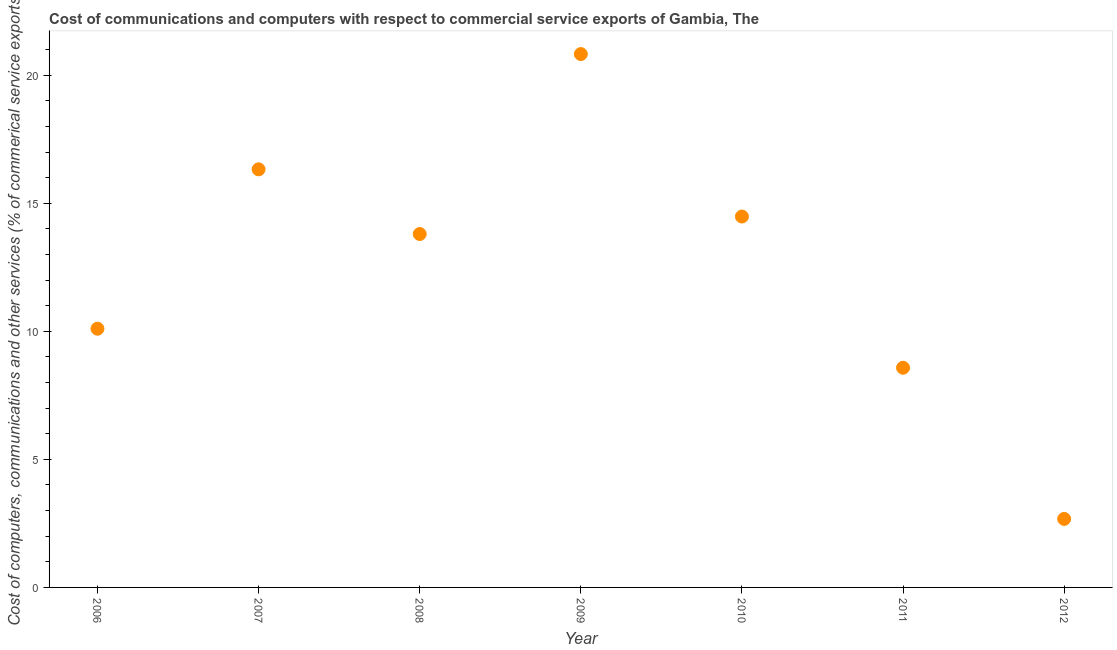What is the cost of communications in 2006?
Your answer should be compact. 10.1. Across all years, what is the maximum  computer and other services?
Ensure brevity in your answer.  20.83. Across all years, what is the minimum cost of communications?
Provide a short and direct response. 2.68. In which year was the cost of communications minimum?
Offer a very short reply. 2012. What is the sum of the cost of communications?
Provide a short and direct response. 86.79. What is the difference between the cost of communications in 2007 and 2012?
Your answer should be compact. 13.65. What is the average cost of communications per year?
Your response must be concise. 12.4. What is the median cost of communications?
Provide a succinct answer. 13.8. In how many years, is the cost of communications greater than 6 %?
Keep it short and to the point. 6. What is the ratio of the  computer and other services in 2008 to that in 2012?
Ensure brevity in your answer.  5.16. Is the  computer and other services in 2007 less than that in 2009?
Give a very brief answer. Yes. What is the difference between the highest and the second highest  computer and other services?
Provide a succinct answer. 4.5. What is the difference between the highest and the lowest  computer and other services?
Provide a succinct answer. 18.15. In how many years, is the  computer and other services greater than the average  computer and other services taken over all years?
Provide a succinct answer. 4. Does the cost of communications monotonically increase over the years?
Make the answer very short. No. What is the difference between two consecutive major ticks on the Y-axis?
Ensure brevity in your answer.  5. Does the graph contain any zero values?
Your answer should be very brief. No. What is the title of the graph?
Provide a succinct answer. Cost of communications and computers with respect to commercial service exports of Gambia, The. What is the label or title of the X-axis?
Your answer should be compact. Year. What is the label or title of the Y-axis?
Make the answer very short. Cost of computers, communications and other services (% of commerical service exports). What is the Cost of computers, communications and other services (% of commerical service exports) in 2006?
Give a very brief answer. 10.1. What is the Cost of computers, communications and other services (% of commerical service exports) in 2007?
Your answer should be compact. 16.33. What is the Cost of computers, communications and other services (% of commerical service exports) in 2008?
Give a very brief answer. 13.8. What is the Cost of computers, communications and other services (% of commerical service exports) in 2009?
Keep it short and to the point. 20.83. What is the Cost of computers, communications and other services (% of commerical service exports) in 2010?
Offer a terse response. 14.48. What is the Cost of computers, communications and other services (% of commerical service exports) in 2011?
Provide a succinct answer. 8.58. What is the Cost of computers, communications and other services (% of commerical service exports) in 2012?
Your answer should be compact. 2.68. What is the difference between the Cost of computers, communications and other services (% of commerical service exports) in 2006 and 2007?
Your answer should be compact. -6.22. What is the difference between the Cost of computers, communications and other services (% of commerical service exports) in 2006 and 2008?
Offer a very short reply. -3.7. What is the difference between the Cost of computers, communications and other services (% of commerical service exports) in 2006 and 2009?
Offer a terse response. -10.72. What is the difference between the Cost of computers, communications and other services (% of commerical service exports) in 2006 and 2010?
Offer a terse response. -4.38. What is the difference between the Cost of computers, communications and other services (% of commerical service exports) in 2006 and 2011?
Offer a very short reply. 1.52. What is the difference between the Cost of computers, communications and other services (% of commerical service exports) in 2006 and 2012?
Provide a succinct answer. 7.43. What is the difference between the Cost of computers, communications and other services (% of commerical service exports) in 2007 and 2008?
Your answer should be very brief. 2.53. What is the difference between the Cost of computers, communications and other services (% of commerical service exports) in 2007 and 2009?
Make the answer very short. -4.5. What is the difference between the Cost of computers, communications and other services (% of commerical service exports) in 2007 and 2010?
Offer a terse response. 1.84. What is the difference between the Cost of computers, communications and other services (% of commerical service exports) in 2007 and 2011?
Provide a short and direct response. 7.75. What is the difference between the Cost of computers, communications and other services (% of commerical service exports) in 2007 and 2012?
Your answer should be compact. 13.65. What is the difference between the Cost of computers, communications and other services (% of commerical service exports) in 2008 and 2009?
Provide a succinct answer. -7.03. What is the difference between the Cost of computers, communications and other services (% of commerical service exports) in 2008 and 2010?
Make the answer very short. -0.68. What is the difference between the Cost of computers, communications and other services (% of commerical service exports) in 2008 and 2011?
Ensure brevity in your answer.  5.22. What is the difference between the Cost of computers, communications and other services (% of commerical service exports) in 2008 and 2012?
Your answer should be compact. 11.12. What is the difference between the Cost of computers, communications and other services (% of commerical service exports) in 2009 and 2010?
Provide a succinct answer. 6.34. What is the difference between the Cost of computers, communications and other services (% of commerical service exports) in 2009 and 2011?
Keep it short and to the point. 12.25. What is the difference between the Cost of computers, communications and other services (% of commerical service exports) in 2009 and 2012?
Your response must be concise. 18.15. What is the difference between the Cost of computers, communications and other services (% of commerical service exports) in 2010 and 2011?
Offer a very short reply. 5.9. What is the difference between the Cost of computers, communications and other services (% of commerical service exports) in 2010 and 2012?
Offer a terse response. 11.81. What is the difference between the Cost of computers, communications and other services (% of commerical service exports) in 2011 and 2012?
Your answer should be very brief. 5.9. What is the ratio of the Cost of computers, communications and other services (% of commerical service exports) in 2006 to that in 2007?
Make the answer very short. 0.62. What is the ratio of the Cost of computers, communications and other services (% of commerical service exports) in 2006 to that in 2008?
Your answer should be compact. 0.73. What is the ratio of the Cost of computers, communications and other services (% of commerical service exports) in 2006 to that in 2009?
Ensure brevity in your answer.  0.48. What is the ratio of the Cost of computers, communications and other services (% of commerical service exports) in 2006 to that in 2010?
Offer a terse response. 0.7. What is the ratio of the Cost of computers, communications and other services (% of commerical service exports) in 2006 to that in 2011?
Provide a succinct answer. 1.18. What is the ratio of the Cost of computers, communications and other services (% of commerical service exports) in 2006 to that in 2012?
Offer a very short reply. 3.78. What is the ratio of the Cost of computers, communications and other services (% of commerical service exports) in 2007 to that in 2008?
Your answer should be compact. 1.18. What is the ratio of the Cost of computers, communications and other services (% of commerical service exports) in 2007 to that in 2009?
Provide a short and direct response. 0.78. What is the ratio of the Cost of computers, communications and other services (% of commerical service exports) in 2007 to that in 2010?
Your response must be concise. 1.13. What is the ratio of the Cost of computers, communications and other services (% of commerical service exports) in 2007 to that in 2011?
Give a very brief answer. 1.9. What is the ratio of the Cost of computers, communications and other services (% of commerical service exports) in 2007 to that in 2012?
Make the answer very short. 6.1. What is the ratio of the Cost of computers, communications and other services (% of commerical service exports) in 2008 to that in 2009?
Provide a succinct answer. 0.66. What is the ratio of the Cost of computers, communications and other services (% of commerical service exports) in 2008 to that in 2010?
Make the answer very short. 0.95. What is the ratio of the Cost of computers, communications and other services (% of commerical service exports) in 2008 to that in 2011?
Ensure brevity in your answer.  1.61. What is the ratio of the Cost of computers, communications and other services (% of commerical service exports) in 2008 to that in 2012?
Your response must be concise. 5.16. What is the ratio of the Cost of computers, communications and other services (% of commerical service exports) in 2009 to that in 2010?
Keep it short and to the point. 1.44. What is the ratio of the Cost of computers, communications and other services (% of commerical service exports) in 2009 to that in 2011?
Your answer should be very brief. 2.43. What is the ratio of the Cost of computers, communications and other services (% of commerical service exports) in 2009 to that in 2012?
Offer a terse response. 7.78. What is the ratio of the Cost of computers, communications and other services (% of commerical service exports) in 2010 to that in 2011?
Offer a very short reply. 1.69. What is the ratio of the Cost of computers, communications and other services (% of commerical service exports) in 2010 to that in 2012?
Give a very brief answer. 5.41. What is the ratio of the Cost of computers, communications and other services (% of commerical service exports) in 2011 to that in 2012?
Your response must be concise. 3.21. 